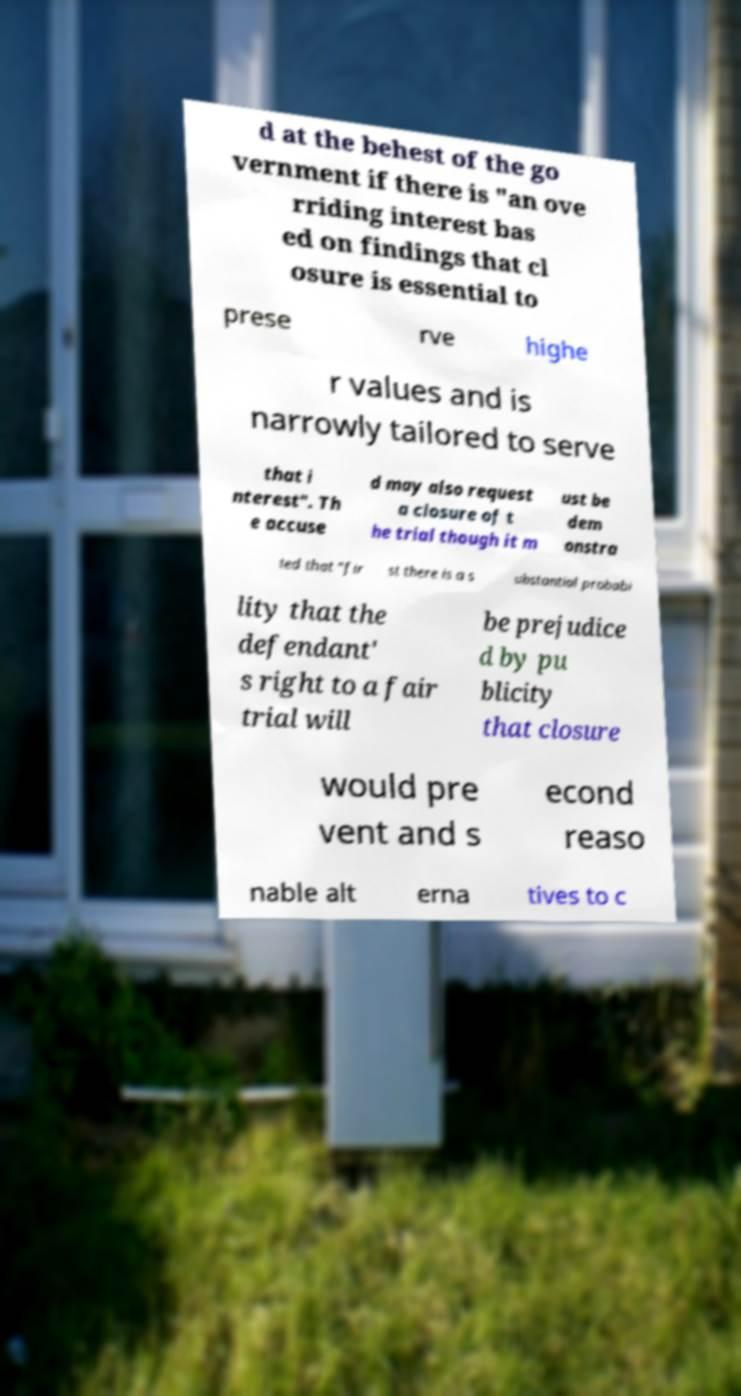Can you accurately transcribe the text from the provided image for me? d at the behest of the go vernment if there is "an ove rriding interest bas ed on findings that cl osure is essential to prese rve highe r values and is narrowly tailored to serve that i nterest". Th e accuse d may also request a closure of t he trial though it m ust be dem onstra ted that "fir st there is a s ubstantial probabi lity that the defendant' s right to a fair trial will be prejudice d by pu blicity that closure would pre vent and s econd reaso nable alt erna tives to c 